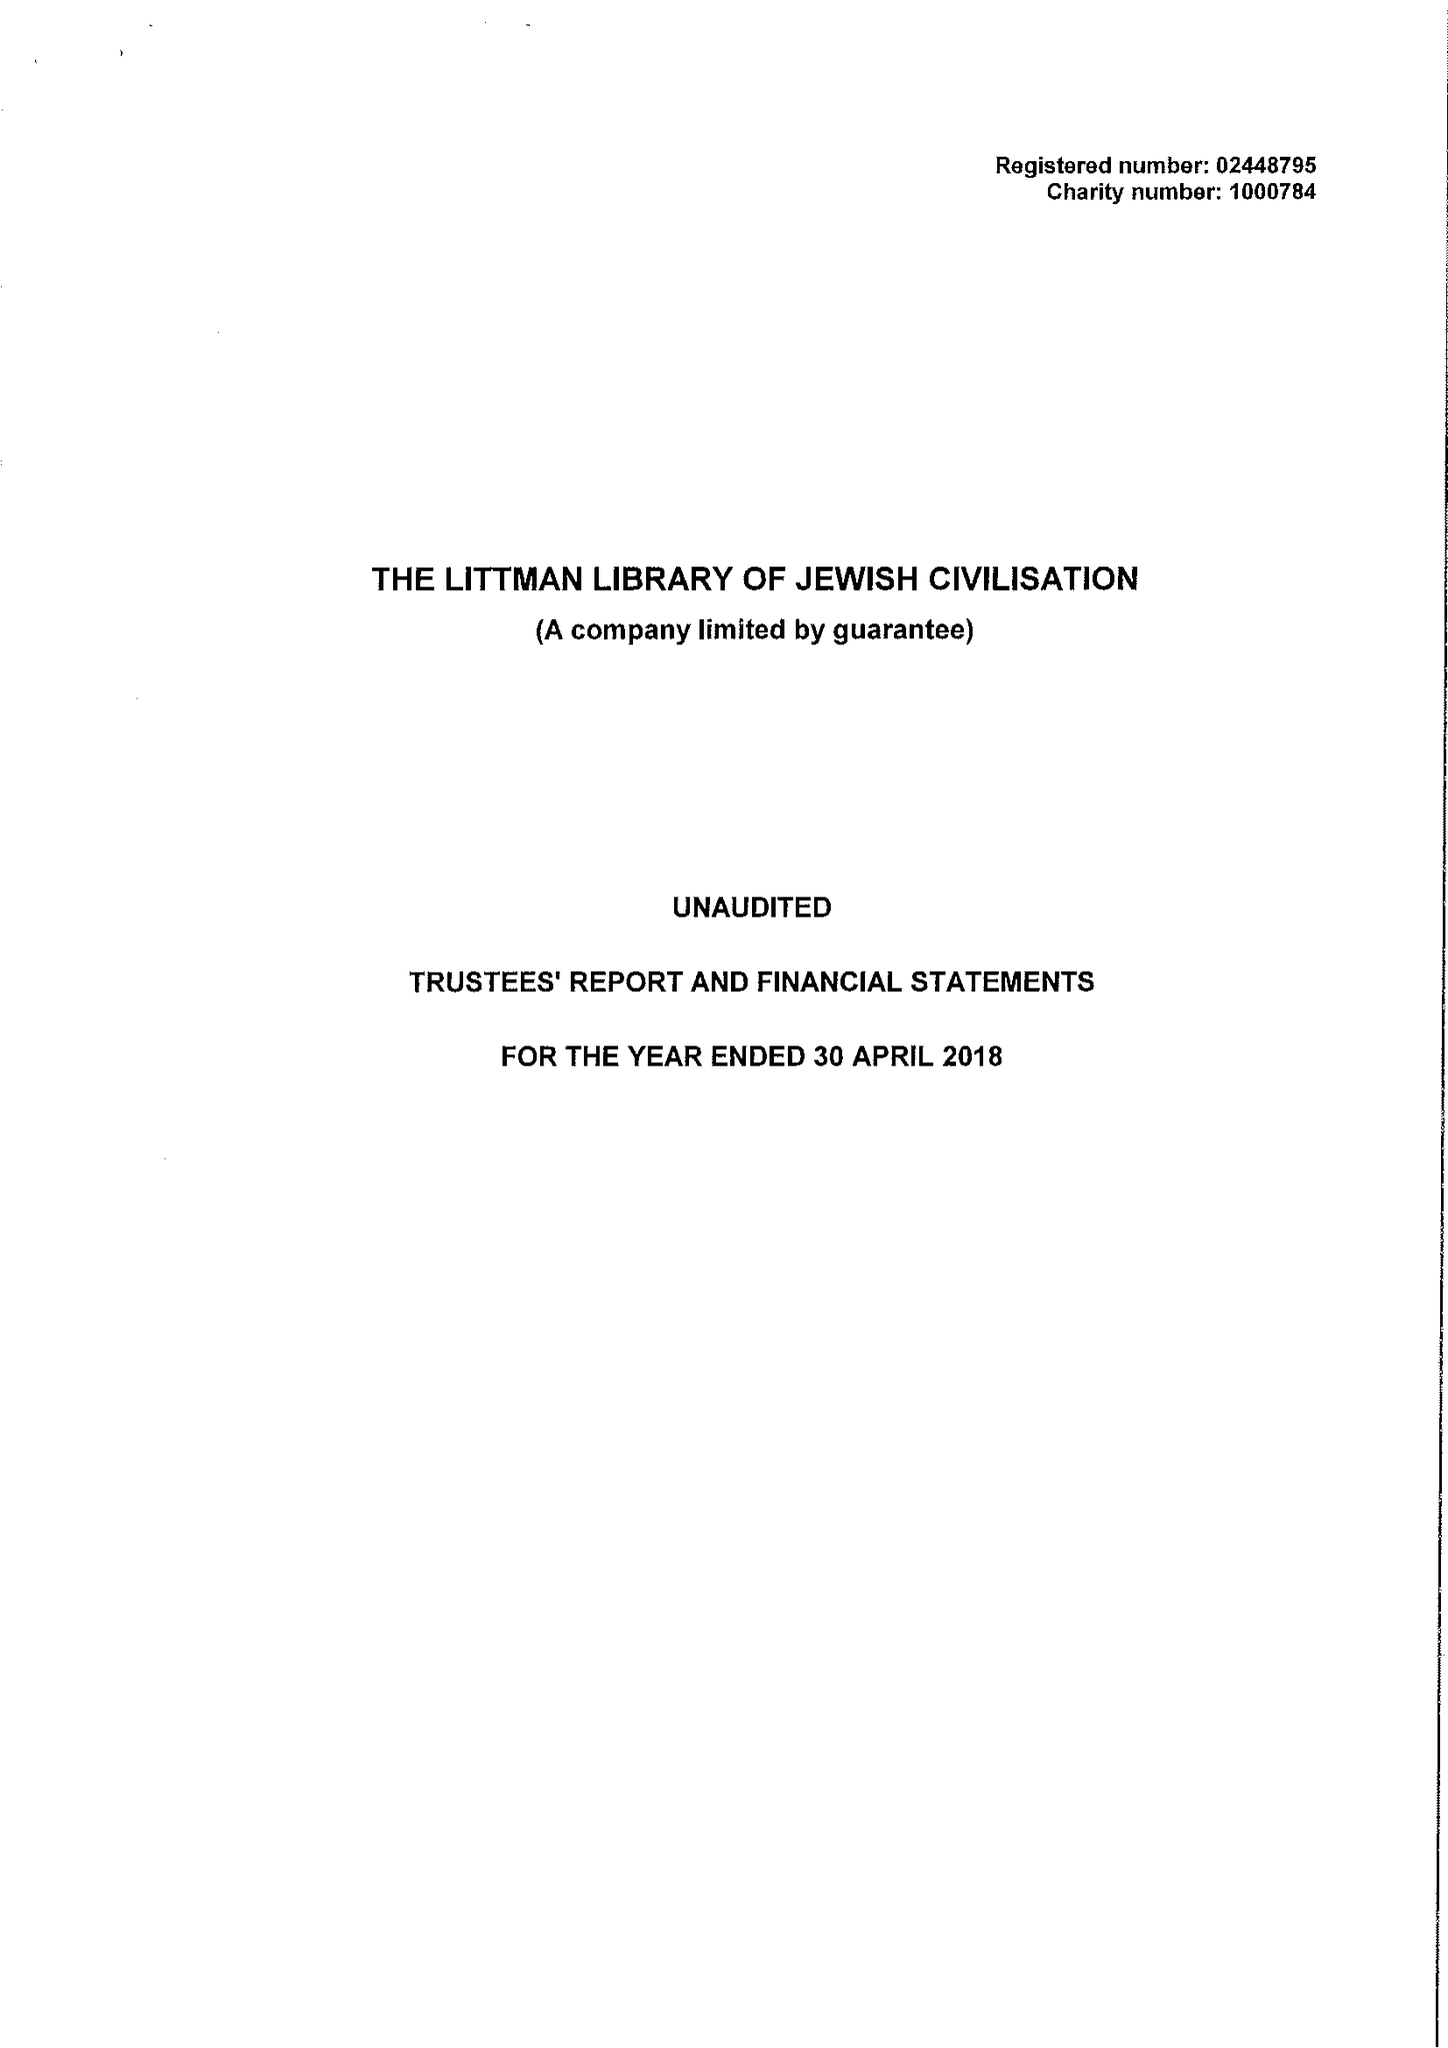What is the value for the income_annually_in_british_pounds?
Answer the question using a single word or phrase. 286065.00 